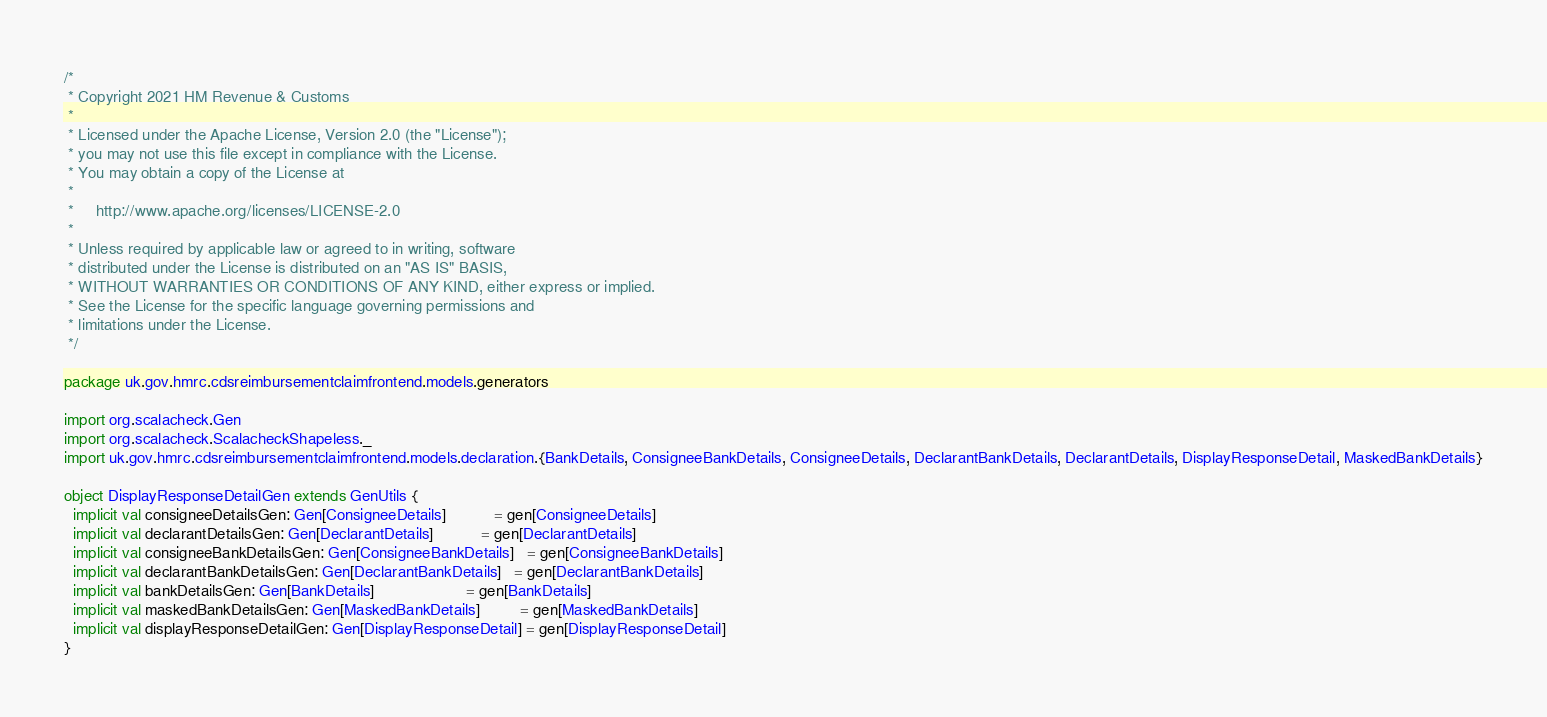<code> <loc_0><loc_0><loc_500><loc_500><_Scala_>/*
 * Copyright 2021 HM Revenue & Customs
 *
 * Licensed under the Apache License, Version 2.0 (the "License");
 * you may not use this file except in compliance with the License.
 * You may obtain a copy of the License at
 *
 *     http://www.apache.org/licenses/LICENSE-2.0
 *
 * Unless required by applicable law or agreed to in writing, software
 * distributed under the License is distributed on an "AS IS" BASIS,
 * WITHOUT WARRANTIES OR CONDITIONS OF ANY KIND, either express or implied.
 * See the License for the specific language governing permissions and
 * limitations under the License.
 */

package uk.gov.hmrc.cdsreimbursementclaimfrontend.models.generators

import org.scalacheck.Gen
import org.scalacheck.ScalacheckShapeless._
import uk.gov.hmrc.cdsreimbursementclaimfrontend.models.declaration.{BankDetails, ConsigneeBankDetails, ConsigneeDetails, DeclarantBankDetails, DeclarantDetails, DisplayResponseDetail, MaskedBankDetails}

object DisplayResponseDetailGen extends GenUtils {
  implicit val consigneeDetailsGen: Gen[ConsigneeDetails]           = gen[ConsigneeDetails]
  implicit val declarantDetailsGen: Gen[DeclarantDetails]           = gen[DeclarantDetails]
  implicit val consigneeBankDetailsGen: Gen[ConsigneeBankDetails]   = gen[ConsigneeBankDetails]
  implicit val declarantBankDetailsGen: Gen[DeclarantBankDetails]   = gen[DeclarantBankDetails]
  implicit val bankDetailsGen: Gen[BankDetails]                     = gen[BankDetails]
  implicit val maskedBankDetailsGen: Gen[MaskedBankDetails]         = gen[MaskedBankDetails]
  implicit val displayResponseDetailGen: Gen[DisplayResponseDetail] = gen[DisplayResponseDetail]
}
</code> 